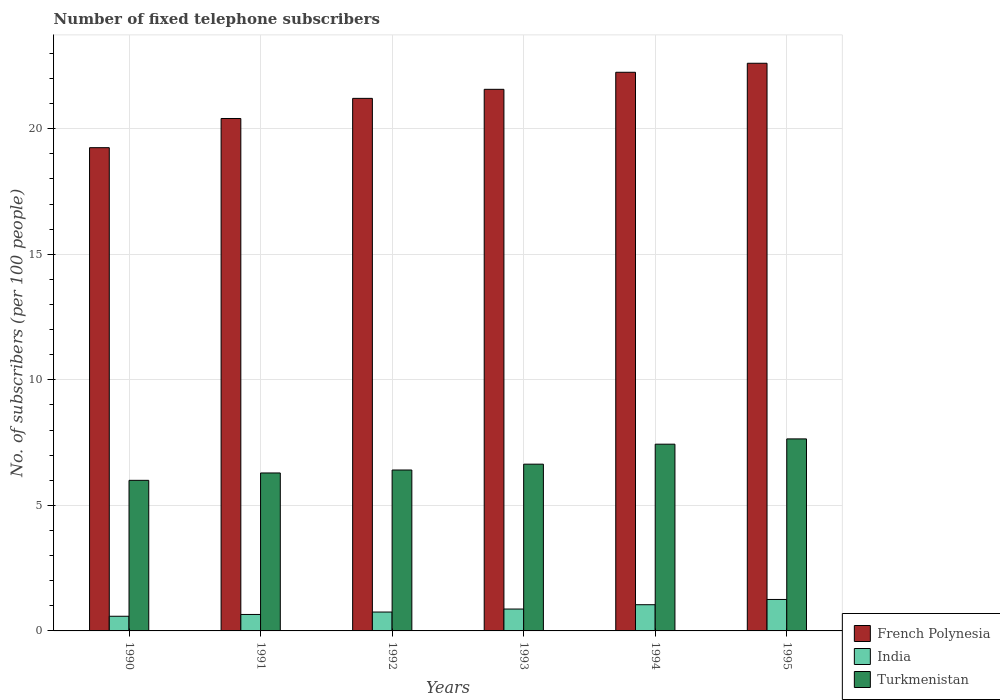How many different coloured bars are there?
Offer a very short reply. 3. How many bars are there on the 5th tick from the left?
Ensure brevity in your answer.  3. In how many cases, is the number of bars for a given year not equal to the number of legend labels?
Your answer should be very brief. 0. What is the number of fixed telephone subscribers in India in 1992?
Give a very brief answer. 0.75. Across all years, what is the maximum number of fixed telephone subscribers in French Polynesia?
Your answer should be very brief. 22.61. Across all years, what is the minimum number of fixed telephone subscribers in Turkmenistan?
Offer a very short reply. 6. In which year was the number of fixed telephone subscribers in India maximum?
Offer a terse response. 1995. In which year was the number of fixed telephone subscribers in India minimum?
Offer a very short reply. 1990. What is the total number of fixed telephone subscribers in Turkmenistan in the graph?
Provide a succinct answer. 40.42. What is the difference between the number of fixed telephone subscribers in Turkmenistan in 1992 and that in 1995?
Make the answer very short. -1.24. What is the difference between the number of fixed telephone subscribers in Turkmenistan in 1992 and the number of fixed telephone subscribers in French Polynesia in 1993?
Offer a very short reply. -15.16. What is the average number of fixed telephone subscribers in Turkmenistan per year?
Keep it short and to the point. 6.74. In the year 1995, what is the difference between the number of fixed telephone subscribers in French Polynesia and number of fixed telephone subscribers in India?
Your response must be concise. 21.36. In how many years, is the number of fixed telephone subscribers in Turkmenistan greater than 18?
Your response must be concise. 0. What is the ratio of the number of fixed telephone subscribers in India in 1992 to that in 1993?
Make the answer very short. 0.86. Is the difference between the number of fixed telephone subscribers in French Polynesia in 1990 and 1994 greater than the difference between the number of fixed telephone subscribers in India in 1990 and 1994?
Provide a short and direct response. No. What is the difference between the highest and the second highest number of fixed telephone subscribers in India?
Provide a short and direct response. 0.21. What is the difference between the highest and the lowest number of fixed telephone subscribers in Turkmenistan?
Provide a short and direct response. 1.65. What does the 2nd bar from the left in 1994 represents?
Your answer should be compact. India. What does the 1st bar from the right in 1995 represents?
Ensure brevity in your answer.  Turkmenistan. Is it the case that in every year, the sum of the number of fixed telephone subscribers in Turkmenistan and number of fixed telephone subscribers in French Polynesia is greater than the number of fixed telephone subscribers in India?
Keep it short and to the point. Yes. How many bars are there?
Offer a very short reply. 18. Are all the bars in the graph horizontal?
Your response must be concise. No. How many years are there in the graph?
Make the answer very short. 6. What is the difference between two consecutive major ticks on the Y-axis?
Your response must be concise. 5. Does the graph contain any zero values?
Offer a very short reply. No. Does the graph contain grids?
Offer a very short reply. Yes. Where does the legend appear in the graph?
Give a very brief answer. Bottom right. What is the title of the graph?
Provide a short and direct response. Number of fixed telephone subscribers. Does "Mozambique" appear as one of the legend labels in the graph?
Provide a succinct answer. No. What is the label or title of the X-axis?
Provide a short and direct response. Years. What is the label or title of the Y-axis?
Your answer should be compact. No. of subscribers (per 100 people). What is the No. of subscribers (per 100 people) in French Polynesia in 1990?
Offer a terse response. 19.25. What is the No. of subscribers (per 100 people) of India in 1990?
Provide a short and direct response. 0.58. What is the No. of subscribers (per 100 people) of Turkmenistan in 1990?
Your response must be concise. 6. What is the No. of subscribers (per 100 people) of French Polynesia in 1991?
Ensure brevity in your answer.  20.41. What is the No. of subscribers (per 100 people) of India in 1991?
Ensure brevity in your answer.  0.66. What is the No. of subscribers (per 100 people) of Turkmenistan in 1991?
Your response must be concise. 6.29. What is the No. of subscribers (per 100 people) in French Polynesia in 1992?
Offer a terse response. 21.21. What is the No. of subscribers (per 100 people) in India in 1992?
Give a very brief answer. 0.75. What is the No. of subscribers (per 100 people) of Turkmenistan in 1992?
Ensure brevity in your answer.  6.41. What is the No. of subscribers (per 100 people) in French Polynesia in 1993?
Your response must be concise. 21.57. What is the No. of subscribers (per 100 people) in India in 1993?
Keep it short and to the point. 0.87. What is the No. of subscribers (per 100 people) of Turkmenistan in 1993?
Make the answer very short. 6.64. What is the No. of subscribers (per 100 people) of French Polynesia in 1994?
Your answer should be compact. 22.25. What is the No. of subscribers (per 100 people) of India in 1994?
Your response must be concise. 1.04. What is the No. of subscribers (per 100 people) of Turkmenistan in 1994?
Keep it short and to the point. 7.44. What is the No. of subscribers (per 100 people) of French Polynesia in 1995?
Offer a very short reply. 22.61. What is the No. of subscribers (per 100 people) of India in 1995?
Your answer should be very brief. 1.25. What is the No. of subscribers (per 100 people) in Turkmenistan in 1995?
Your answer should be compact. 7.65. Across all years, what is the maximum No. of subscribers (per 100 people) in French Polynesia?
Ensure brevity in your answer.  22.61. Across all years, what is the maximum No. of subscribers (per 100 people) in India?
Offer a very short reply. 1.25. Across all years, what is the maximum No. of subscribers (per 100 people) of Turkmenistan?
Give a very brief answer. 7.65. Across all years, what is the minimum No. of subscribers (per 100 people) in French Polynesia?
Provide a short and direct response. 19.25. Across all years, what is the minimum No. of subscribers (per 100 people) in India?
Your answer should be compact. 0.58. Across all years, what is the minimum No. of subscribers (per 100 people) of Turkmenistan?
Ensure brevity in your answer.  6. What is the total No. of subscribers (per 100 people) in French Polynesia in the graph?
Offer a very short reply. 127.3. What is the total No. of subscribers (per 100 people) of India in the graph?
Keep it short and to the point. 5.16. What is the total No. of subscribers (per 100 people) of Turkmenistan in the graph?
Your response must be concise. 40.42. What is the difference between the No. of subscribers (per 100 people) of French Polynesia in 1990 and that in 1991?
Your response must be concise. -1.16. What is the difference between the No. of subscribers (per 100 people) in India in 1990 and that in 1991?
Your response must be concise. -0.07. What is the difference between the No. of subscribers (per 100 people) in Turkmenistan in 1990 and that in 1991?
Keep it short and to the point. -0.29. What is the difference between the No. of subscribers (per 100 people) of French Polynesia in 1990 and that in 1992?
Your answer should be very brief. -1.96. What is the difference between the No. of subscribers (per 100 people) in India in 1990 and that in 1992?
Ensure brevity in your answer.  -0.17. What is the difference between the No. of subscribers (per 100 people) of Turkmenistan in 1990 and that in 1992?
Ensure brevity in your answer.  -0.41. What is the difference between the No. of subscribers (per 100 people) in French Polynesia in 1990 and that in 1993?
Your response must be concise. -2.32. What is the difference between the No. of subscribers (per 100 people) of India in 1990 and that in 1993?
Your answer should be compact. -0.29. What is the difference between the No. of subscribers (per 100 people) in Turkmenistan in 1990 and that in 1993?
Keep it short and to the point. -0.64. What is the difference between the No. of subscribers (per 100 people) in French Polynesia in 1990 and that in 1994?
Your answer should be very brief. -3. What is the difference between the No. of subscribers (per 100 people) of India in 1990 and that in 1994?
Your answer should be very brief. -0.46. What is the difference between the No. of subscribers (per 100 people) in Turkmenistan in 1990 and that in 1994?
Provide a short and direct response. -1.44. What is the difference between the No. of subscribers (per 100 people) in French Polynesia in 1990 and that in 1995?
Make the answer very short. -3.36. What is the difference between the No. of subscribers (per 100 people) in India in 1990 and that in 1995?
Your answer should be compact. -0.67. What is the difference between the No. of subscribers (per 100 people) in Turkmenistan in 1990 and that in 1995?
Your answer should be compact. -1.65. What is the difference between the No. of subscribers (per 100 people) in French Polynesia in 1991 and that in 1992?
Keep it short and to the point. -0.8. What is the difference between the No. of subscribers (per 100 people) in India in 1991 and that in 1992?
Your answer should be very brief. -0.1. What is the difference between the No. of subscribers (per 100 people) in Turkmenistan in 1991 and that in 1992?
Your answer should be very brief. -0.12. What is the difference between the No. of subscribers (per 100 people) in French Polynesia in 1991 and that in 1993?
Your response must be concise. -1.16. What is the difference between the No. of subscribers (per 100 people) of India in 1991 and that in 1993?
Keep it short and to the point. -0.22. What is the difference between the No. of subscribers (per 100 people) in Turkmenistan in 1991 and that in 1993?
Give a very brief answer. -0.35. What is the difference between the No. of subscribers (per 100 people) in French Polynesia in 1991 and that in 1994?
Ensure brevity in your answer.  -1.84. What is the difference between the No. of subscribers (per 100 people) of India in 1991 and that in 1994?
Provide a short and direct response. -0.39. What is the difference between the No. of subscribers (per 100 people) of Turkmenistan in 1991 and that in 1994?
Give a very brief answer. -1.15. What is the difference between the No. of subscribers (per 100 people) in French Polynesia in 1991 and that in 1995?
Keep it short and to the point. -2.2. What is the difference between the No. of subscribers (per 100 people) of India in 1991 and that in 1995?
Provide a short and direct response. -0.6. What is the difference between the No. of subscribers (per 100 people) in Turkmenistan in 1991 and that in 1995?
Provide a short and direct response. -1.36. What is the difference between the No. of subscribers (per 100 people) of French Polynesia in 1992 and that in 1993?
Offer a very short reply. -0.36. What is the difference between the No. of subscribers (per 100 people) in India in 1992 and that in 1993?
Your answer should be very brief. -0.12. What is the difference between the No. of subscribers (per 100 people) of Turkmenistan in 1992 and that in 1993?
Give a very brief answer. -0.23. What is the difference between the No. of subscribers (per 100 people) in French Polynesia in 1992 and that in 1994?
Offer a terse response. -1.04. What is the difference between the No. of subscribers (per 100 people) in India in 1992 and that in 1994?
Offer a very short reply. -0.29. What is the difference between the No. of subscribers (per 100 people) of Turkmenistan in 1992 and that in 1994?
Give a very brief answer. -1.03. What is the difference between the No. of subscribers (per 100 people) of French Polynesia in 1992 and that in 1995?
Keep it short and to the point. -1.4. What is the difference between the No. of subscribers (per 100 people) in India in 1992 and that in 1995?
Offer a very short reply. -0.5. What is the difference between the No. of subscribers (per 100 people) in Turkmenistan in 1992 and that in 1995?
Provide a short and direct response. -1.24. What is the difference between the No. of subscribers (per 100 people) in French Polynesia in 1993 and that in 1994?
Provide a succinct answer. -0.68. What is the difference between the No. of subscribers (per 100 people) in India in 1993 and that in 1994?
Your answer should be very brief. -0.17. What is the difference between the No. of subscribers (per 100 people) in Turkmenistan in 1993 and that in 1994?
Your answer should be very brief. -0.8. What is the difference between the No. of subscribers (per 100 people) of French Polynesia in 1993 and that in 1995?
Provide a short and direct response. -1.04. What is the difference between the No. of subscribers (per 100 people) of India in 1993 and that in 1995?
Provide a short and direct response. -0.38. What is the difference between the No. of subscribers (per 100 people) of Turkmenistan in 1993 and that in 1995?
Make the answer very short. -1.01. What is the difference between the No. of subscribers (per 100 people) in French Polynesia in 1994 and that in 1995?
Provide a short and direct response. -0.36. What is the difference between the No. of subscribers (per 100 people) of India in 1994 and that in 1995?
Ensure brevity in your answer.  -0.21. What is the difference between the No. of subscribers (per 100 people) of Turkmenistan in 1994 and that in 1995?
Provide a succinct answer. -0.21. What is the difference between the No. of subscribers (per 100 people) of French Polynesia in 1990 and the No. of subscribers (per 100 people) of India in 1991?
Offer a terse response. 18.59. What is the difference between the No. of subscribers (per 100 people) of French Polynesia in 1990 and the No. of subscribers (per 100 people) of Turkmenistan in 1991?
Make the answer very short. 12.96. What is the difference between the No. of subscribers (per 100 people) in India in 1990 and the No. of subscribers (per 100 people) in Turkmenistan in 1991?
Your answer should be very brief. -5.71. What is the difference between the No. of subscribers (per 100 people) of French Polynesia in 1990 and the No. of subscribers (per 100 people) of India in 1992?
Your answer should be very brief. 18.49. What is the difference between the No. of subscribers (per 100 people) in French Polynesia in 1990 and the No. of subscribers (per 100 people) in Turkmenistan in 1992?
Provide a short and direct response. 12.84. What is the difference between the No. of subscribers (per 100 people) in India in 1990 and the No. of subscribers (per 100 people) in Turkmenistan in 1992?
Offer a very short reply. -5.82. What is the difference between the No. of subscribers (per 100 people) in French Polynesia in 1990 and the No. of subscribers (per 100 people) in India in 1993?
Provide a short and direct response. 18.38. What is the difference between the No. of subscribers (per 100 people) of French Polynesia in 1990 and the No. of subscribers (per 100 people) of Turkmenistan in 1993?
Offer a very short reply. 12.61. What is the difference between the No. of subscribers (per 100 people) of India in 1990 and the No. of subscribers (per 100 people) of Turkmenistan in 1993?
Offer a terse response. -6.06. What is the difference between the No. of subscribers (per 100 people) of French Polynesia in 1990 and the No. of subscribers (per 100 people) of India in 1994?
Keep it short and to the point. 18.2. What is the difference between the No. of subscribers (per 100 people) in French Polynesia in 1990 and the No. of subscribers (per 100 people) in Turkmenistan in 1994?
Give a very brief answer. 11.81. What is the difference between the No. of subscribers (per 100 people) in India in 1990 and the No. of subscribers (per 100 people) in Turkmenistan in 1994?
Give a very brief answer. -6.85. What is the difference between the No. of subscribers (per 100 people) in French Polynesia in 1990 and the No. of subscribers (per 100 people) in India in 1995?
Your response must be concise. 17.99. What is the difference between the No. of subscribers (per 100 people) of French Polynesia in 1990 and the No. of subscribers (per 100 people) of Turkmenistan in 1995?
Your response must be concise. 11.6. What is the difference between the No. of subscribers (per 100 people) of India in 1990 and the No. of subscribers (per 100 people) of Turkmenistan in 1995?
Your answer should be compact. -7.06. What is the difference between the No. of subscribers (per 100 people) of French Polynesia in 1991 and the No. of subscribers (per 100 people) of India in 1992?
Offer a terse response. 19.66. What is the difference between the No. of subscribers (per 100 people) in French Polynesia in 1991 and the No. of subscribers (per 100 people) in Turkmenistan in 1992?
Offer a terse response. 14. What is the difference between the No. of subscribers (per 100 people) of India in 1991 and the No. of subscribers (per 100 people) of Turkmenistan in 1992?
Provide a short and direct response. -5.75. What is the difference between the No. of subscribers (per 100 people) of French Polynesia in 1991 and the No. of subscribers (per 100 people) of India in 1993?
Your answer should be compact. 19.54. What is the difference between the No. of subscribers (per 100 people) in French Polynesia in 1991 and the No. of subscribers (per 100 people) in Turkmenistan in 1993?
Offer a very short reply. 13.77. What is the difference between the No. of subscribers (per 100 people) of India in 1991 and the No. of subscribers (per 100 people) of Turkmenistan in 1993?
Provide a succinct answer. -5.99. What is the difference between the No. of subscribers (per 100 people) of French Polynesia in 1991 and the No. of subscribers (per 100 people) of India in 1994?
Provide a succinct answer. 19.37. What is the difference between the No. of subscribers (per 100 people) of French Polynesia in 1991 and the No. of subscribers (per 100 people) of Turkmenistan in 1994?
Offer a terse response. 12.97. What is the difference between the No. of subscribers (per 100 people) in India in 1991 and the No. of subscribers (per 100 people) in Turkmenistan in 1994?
Provide a succinct answer. -6.78. What is the difference between the No. of subscribers (per 100 people) in French Polynesia in 1991 and the No. of subscribers (per 100 people) in India in 1995?
Keep it short and to the point. 19.16. What is the difference between the No. of subscribers (per 100 people) of French Polynesia in 1991 and the No. of subscribers (per 100 people) of Turkmenistan in 1995?
Your response must be concise. 12.76. What is the difference between the No. of subscribers (per 100 people) of India in 1991 and the No. of subscribers (per 100 people) of Turkmenistan in 1995?
Ensure brevity in your answer.  -6.99. What is the difference between the No. of subscribers (per 100 people) in French Polynesia in 1992 and the No. of subscribers (per 100 people) in India in 1993?
Offer a terse response. 20.34. What is the difference between the No. of subscribers (per 100 people) in French Polynesia in 1992 and the No. of subscribers (per 100 people) in Turkmenistan in 1993?
Your response must be concise. 14.57. What is the difference between the No. of subscribers (per 100 people) in India in 1992 and the No. of subscribers (per 100 people) in Turkmenistan in 1993?
Your answer should be very brief. -5.89. What is the difference between the No. of subscribers (per 100 people) in French Polynesia in 1992 and the No. of subscribers (per 100 people) in India in 1994?
Provide a succinct answer. 20.17. What is the difference between the No. of subscribers (per 100 people) in French Polynesia in 1992 and the No. of subscribers (per 100 people) in Turkmenistan in 1994?
Make the answer very short. 13.77. What is the difference between the No. of subscribers (per 100 people) of India in 1992 and the No. of subscribers (per 100 people) of Turkmenistan in 1994?
Provide a succinct answer. -6.69. What is the difference between the No. of subscribers (per 100 people) of French Polynesia in 1992 and the No. of subscribers (per 100 people) of India in 1995?
Your answer should be compact. 19.96. What is the difference between the No. of subscribers (per 100 people) in French Polynesia in 1992 and the No. of subscribers (per 100 people) in Turkmenistan in 1995?
Provide a short and direct response. 13.56. What is the difference between the No. of subscribers (per 100 people) of India in 1992 and the No. of subscribers (per 100 people) of Turkmenistan in 1995?
Keep it short and to the point. -6.9. What is the difference between the No. of subscribers (per 100 people) in French Polynesia in 1993 and the No. of subscribers (per 100 people) in India in 1994?
Keep it short and to the point. 20.53. What is the difference between the No. of subscribers (per 100 people) of French Polynesia in 1993 and the No. of subscribers (per 100 people) of Turkmenistan in 1994?
Offer a very short reply. 14.13. What is the difference between the No. of subscribers (per 100 people) in India in 1993 and the No. of subscribers (per 100 people) in Turkmenistan in 1994?
Provide a succinct answer. -6.57. What is the difference between the No. of subscribers (per 100 people) in French Polynesia in 1993 and the No. of subscribers (per 100 people) in India in 1995?
Provide a succinct answer. 20.32. What is the difference between the No. of subscribers (per 100 people) in French Polynesia in 1993 and the No. of subscribers (per 100 people) in Turkmenistan in 1995?
Your answer should be compact. 13.92. What is the difference between the No. of subscribers (per 100 people) in India in 1993 and the No. of subscribers (per 100 people) in Turkmenistan in 1995?
Make the answer very short. -6.78. What is the difference between the No. of subscribers (per 100 people) in French Polynesia in 1994 and the No. of subscribers (per 100 people) in India in 1995?
Make the answer very short. 21. What is the difference between the No. of subscribers (per 100 people) in French Polynesia in 1994 and the No. of subscribers (per 100 people) in Turkmenistan in 1995?
Keep it short and to the point. 14.6. What is the difference between the No. of subscribers (per 100 people) in India in 1994 and the No. of subscribers (per 100 people) in Turkmenistan in 1995?
Your response must be concise. -6.6. What is the average No. of subscribers (per 100 people) in French Polynesia per year?
Ensure brevity in your answer.  21.22. What is the average No. of subscribers (per 100 people) in India per year?
Your response must be concise. 0.86. What is the average No. of subscribers (per 100 people) in Turkmenistan per year?
Your answer should be very brief. 6.74. In the year 1990, what is the difference between the No. of subscribers (per 100 people) in French Polynesia and No. of subscribers (per 100 people) in India?
Ensure brevity in your answer.  18.66. In the year 1990, what is the difference between the No. of subscribers (per 100 people) of French Polynesia and No. of subscribers (per 100 people) of Turkmenistan?
Provide a short and direct response. 13.25. In the year 1990, what is the difference between the No. of subscribers (per 100 people) of India and No. of subscribers (per 100 people) of Turkmenistan?
Your answer should be compact. -5.41. In the year 1991, what is the difference between the No. of subscribers (per 100 people) of French Polynesia and No. of subscribers (per 100 people) of India?
Your answer should be compact. 19.75. In the year 1991, what is the difference between the No. of subscribers (per 100 people) in French Polynesia and No. of subscribers (per 100 people) in Turkmenistan?
Provide a short and direct response. 14.12. In the year 1991, what is the difference between the No. of subscribers (per 100 people) of India and No. of subscribers (per 100 people) of Turkmenistan?
Your response must be concise. -5.64. In the year 1992, what is the difference between the No. of subscribers (per 100 people) in French Polynesia and No. of subscribers (per 100 people) in India?
Your response must be concise. 20.46. In the year 1992, what is the difference between the No. of subscribers (per 100 people) in French Polynesia and No. of subscribers (per 100 people) in Turkmenistan?
Offer a very short reply. 14.8. In the year 1992, what is the difference between the No. of subscribers (per 100 people) in India and No. of subscribers (per 100 people) in Turkmenistan?
Make the answer very short. -5.66. In the year 1993, what is the difference between the No. of subscribers (per 100 people) in French Polynesia and No. of subscribers (per 100 people) in India?
Provide a succinct answer. 20.7. In the year 1993, what is the difference between the No. of subscribers (per 100 people) in French Polynesia and No. of subscribers (per 100 people) in Turkmenistan?
Provide a short and direct response. 14.93. In the year 1993, what is the difference between the No. of subscribers (per 100 people) of India and No. of subscribers (per 100 people) of Turkmenistan?
Your answer should be compact. -5.77. In the year 1994, what is the difference between the No. of subscribers (per 100 people) in French Polynesia and No. of subscribers (per 100 people) in India?
Your response must be concise. 21.21. In the year 1994, what is the difference between the No. of subscribers (per 100 people) of French Polynesia and No. of subscribers (per 100 people) of Turkmenistan?
Your response must be concise. 14.81. In the year 1994, what is the difference between the No. of subscribers (per 100 people) of India and No. of subscribers (per 100 people) of Turkmenistan?
Provide a succinct answer. -6.39. In the year 1995, what is the difference between the No. of subscribers (per 100 people) in French Polynesia and No. of subscribers (per 100 people) in India?
Provide a short and direct response. 21.36. In the year 1995, what is the difference between the No. of subscribers (per 100 people) of French Polynesia and No. of subscribers (per 100 people) of Turkmenistan?
Ensure brevity in your answer.  14.96. In the year 1995, what is the difference between the No. of subscribers (per 100 people) of India and No. of subscribers (per 100 people) of Turkmenistan?
Keep it short and to the point. -6.39. What is the ratio of the No. of subscribers (per 100 people) of French Polynesia in 1990 to that in 1991?
Give a very brief answer. 0.94. What is the ratio of the No. of subscribers (per 100 people) of India in 1990 to that in 1991?
Your answer should be compact. 0.89. What is the ratio of the No. of subscribers (per 100 people) of Turkmenistan in 1990 to that in 1991?
Provide a succinct answer. 0.95. What is the ratio of the No. of subscribers (per 100 people) of French Polynesia in 1990 to that in 1992?
Give a very brief answer. 0.91. What is the ratio of the No. of subscribers (per 100 people) in India in 1990 to that in 1992?
Your response must be concise. 0.78. What is the ratio of the No. of subscribers (per 100 people) of Turkmenistan in 1990 to that in 1992?
Keep it short and to the point. 0.94. What is the ratio of the No. of subscribers (per 100 people) of French Polynesia in 1990 to that in 1993?
Give a very brief answer. 0.89. What is the ratio of the No. of subscribers (per 100 people) in India in 1990 to that in 1993?
Give a very brief answer. 0.67. What is the ratio of the No. of subscribers (per 100 people) in Turkmenistan in 1990 to that in 1993?
Provide a short and direct response. 0.9. What is the ratio of the No. of subscribers (per 100 people) of French Polynesia in 1990 to that in 1994?
Your answer should be compact. 0.86. What is the ratio of the No. of subscribers (per 100 people) in India in 1990 to that in 1994?
Your answer should be compact. 0.56. What is the ratio of the No. of subscribers (per 100 people) in Turkmenistan in 1990 to that in 1994?
Offer a terse response. 0.81. What is the ratio of the No. of subscribers (per 100 people) of French Polynesia in 1990 to that in 1995?
Keep it short and to the point. 0.85. What is the ratio of the No. of subscribers (per 100 people) in India in 1990 to that in 1995?
Provide a succinct answer. 0.47. What is the ratio of the No. of subscribers (per 100 people) of Turkmenistan in 1990 to that in 1995?
Give a very brief answer. 0.78. What is the ratio of the No. of subscribers (per 100 people) of French Polynesia in 1991 to that in 1992?
Your response must be concise. 0.96. What is the ratio of the No. of subscribers (per 100 people) of India in 1991 to that in 1992?
Provide a succinct answer. 0.87. What is the ratio of the No. of subscribers (per 100 people) in Turkmenistan in 1991 to that in 1992?
Your answer should be very brief. 0.98. What is the ratio of the No. of subscribers (per 100 people) in French Polynesia in 1991 to that in 1993?
Ensure brevity in your answer.  0.95. What is the ratio of the No. of subscribers (per 100 people) of India in 1991 to that in 1993?
Keep it short and to the point. 0.75. What is the ratio of the No. of subscribers (per 100 people) in Turkmenistan in 1991 to that in 1993?
Provide a succinct answer. 0.95. What is the ratio of the No. of subscribers (per 100 people) of French Polynesia in 1991 to that in 1994?
Your response must be concise. 0.92. What is the ratio of the No. of subscribers (per 100 people) of India in 1991 to that in 1994?
Provide a succinct answer. 0.63. What is the ratio of the No. of subscribers (per 100 people) of Turkmenistan in 1991 to that in 1994?
Offer a very short reply. 0.85. What is the ratio of the No. of subscribers (per 100 people) of French Polynesia in 1991 to that in 1995?
Ensure brevity in your answer.  0.9. What is the ratio of the No. of subscribers (per 100 people) of India in 1991 to that in 1995?
Offer a very short reply. 0.52. What is the ratio of the No. of subscribers (per 100 people) of Turkmenistan in 1991 to that in 1995?
Keep it short and to the point. 0.82. What is the ratio of the No. of subscribers (per 100 people) of French Polynesia in 1992 to that in 1993?
Your response must be concise. 0.98. What is the ratio of the No. of subscribers (per 100 people) of India in 1992 to that in 1993?
Provide a short and direct response. 0.86. What is the ratio of the No. of subscribers (per 100 people) of Turkmenistan in 1992 to that in 1993?
Your response must be concise. 0.96. What is the ratio of the No. of subscribers (per 100 people) in French Polynesia in 1992 to that in 1994?
Ensure brevity in your answer.  0.95. What is the ratio of the No. of subscribers (per 100 people) of India in 1992 to that in 1994?
Provide a succinct answer. 0.72. What is the ratio of the No. of subscribers (per 100 people) of Turkmenistan in 1992 to that in 1994?
Your answer should be very brief. 0.86. What is the ratio of the No. of subscribers (per 100 people) of French Polynesia in 1992 to that in 1995?
Offer a terse response. 0.94. What is the ratio of the No. of subscribers (per 100 people) of India in 1992 to that in 1995?
Ensure brevity in your answer.  0.6. What is the ratio of the No. of subscribers (per 100 people) of Turkmenistan in 1992 to that in 1995?
Provide a short and direct response. 0.84. What is the ratio of the No. of subscribers (per 100 people) in French Polynesia in 1993 to that in 1994?
Provide a succinct answer. 0.97. What is the ratio of the No. of subscribers (per 100 people) in India in 1993 to that in 1994?
Your answer should be compact. 0.83. What is the ratio of the No. of subscribers (per 100 people) in Turkmenistan in 1993 to that in 1994?
Your response must be concise. 0.89. What is the ratio of the No. of subscribers (per 100 people) in French Polynesia in 1993 to that in 1995?
Keep it short and to the point. 0.95. What is the ratio of the No. of subscribers (per 100 people) in India in 1993 to that in 1995?
Your response must be concise. 0.7. What is the ratio of the No. of subscribers (per 100 people) in Turkmenistan in 1993 to that in 1995?
Keep it short and to the point. 0.87. What is the ratio of the No. of subscribers (per 100 people) of French Polynesia in 1994 to that in 1995?
Provide a succinct answer. 0.98. What is the ratio of the No. of subscribers (per 100 people) in India in 1994 to that in 1995?
Provide a succinct answer. 0.83. What is the ratio of the No. of subscribers (per 100 people) in Turkmenistan in 1994 to that in 1995?
Ensure brevity in your answer.  0.97. What is the difference between the highest and the second highest No. of subscribers (per 100 people) in French Polynesia?
Provide a succinct answer. 0.36. What is the difference between the highest and the second highest No. of subscribers (per 100 people) of India?
Your response must be concise. 0.21. What is the difference between the highest and the second highest No. of subscribers (per 100 people) in Turkmenistan?
Offer a very short reply. 0.21. What is the difference between the highest and the lowest No. of subscribers (per 100 people) of French Polynesia?
Ensure brevity in your answer.  3.36. What is the difference between the highest and the lowest No. of subscribers (per 100 people) in India?
Give a very brief answer. 0.67. What is the difference between the highest and the lowest No. of subscribers (per 100 people) in Turkmenistan?
Keep it short and to the point. 1.65. 